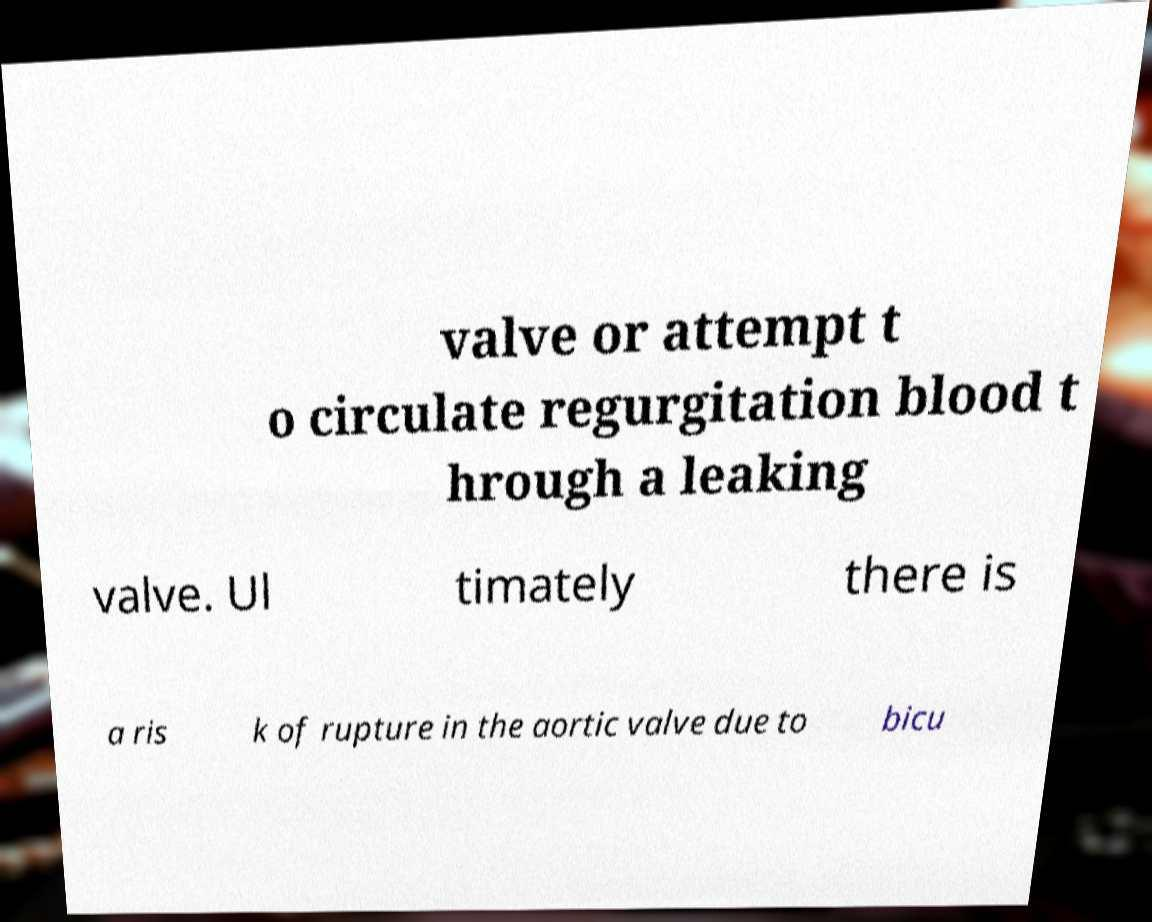Please read and relay the text visible in this image. What does it say? valve or attempt t o circulate regurgitation blood t hrough a leaking valve. Ul timately there is a ris k of rupture in the aortic valve due to bicu 